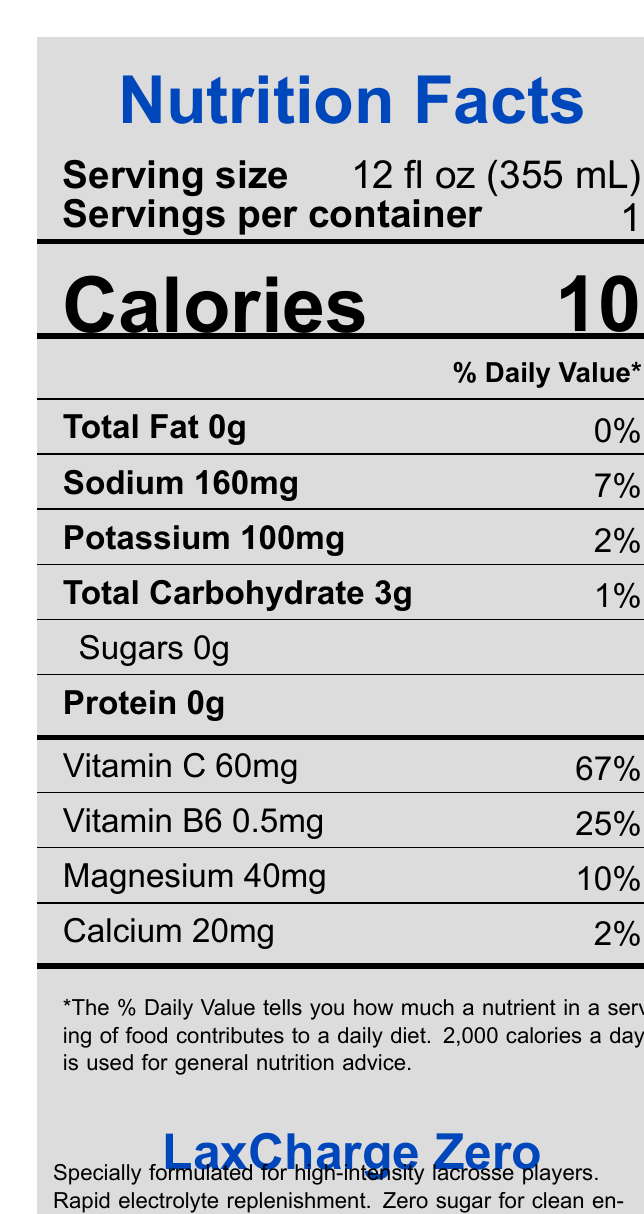What is the serving size of LaxCharge Zero? The serving size is directly stated on the document as 12 fl oz (355 mL).
Answer: 12 fl oz (355 mL) How many calories are in one serving of LaxCharge Zero? The document lists the calories per serving as 10.
Answer: 10 What percentage of the daily value of vitamin C is provided by LaxCharge Zero? The document shows that LaxCharge Zero provides 67% of the daily value of vitamin C.
Answer: 67% How much sodium is in LaxCharge Zero? The document lists the sodium content as 160mg, which is 7% of the daily value.
Answer: 160mg Are there any sugars in LaxCharge Zero? The document indicates that there are 0g of sugars in LaxCharge Zero.
Answer: No Which of the following nutrients is present in the highest percentage of the daily value in LaxCharge Zero? A. Vitamin B6 B. Calcium C. Magnesium D. Vitamin C The document shows that vitamin C is present in the highest percentage of the daily value at 67%, followed by vitamin B6 at 25%, magnesium at 10%, and calcium at 2%.
Answer: D. Vitamin C How many grams of protein does LaxCharge Zero contain? A. 0g B. 1g C. 3g D. 5g The document states that LaxCharge Zero contains 0g of protein.
Answer: A. 0g Is LaxCharge Zero sugar-free? The document clearly states that the product contains 0g of sugars.
Answer: Yes Is LaxCharge Zero endorsed by a professional lacrosse player? The additional information section mentions that it is endorsed by professional lacrosse player Paul Rabil.
Answer: Yes Summarize the main idea of the document. The document provides detailed nutrition information, ingredients, allergen info, and highlights the product's benefits tailored for lacrosse players.
Answer: LaxCharge Zero is a sugar-free, electrolyte-rich sports drink designed specifically for lacrosse players. It provides a rapid replenishment of electrolytes without added sugars and is endorsed by professional lacrosse player Paul Rabil. Each 12 fl oz serving contains 10 calories and significant amounts of vitamin C, vitamin B6, magnesium, and other essential nutrients. Where is information about the marketing or distribution locations found on the document? The document provides nutritional information and a brief product description, but specific marketing or distribution locations are not mentioned.
Answer: Cannot be determined 